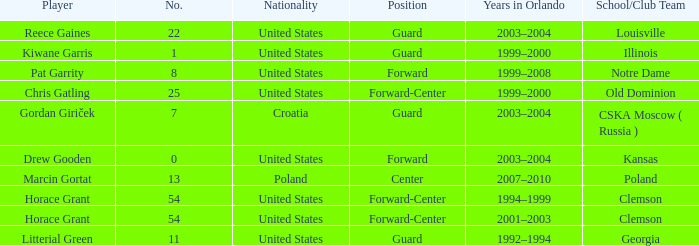What is the number of players in notre dame? 1.0. 